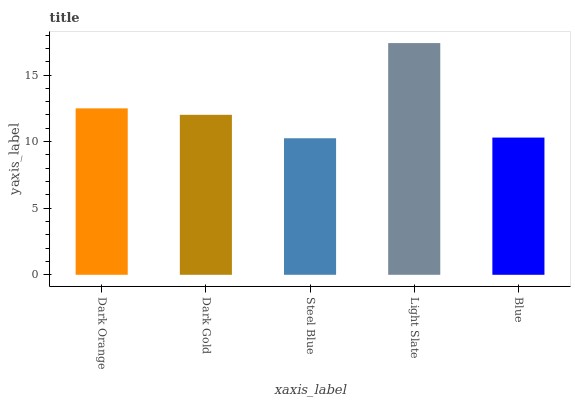Is Steel Blue the minimum?
Answer yes or no. Yes. Is Light Slate the maximum?
Answer yes or no. Yes. Is Dark Gold the minimum?
Answer yes or no. No. Is Dark Gold the maximum?
Answer yes or no. No. Is Dark Orange greater than Dark Gold?
Answer yes or no. Yes. Is Dark Gold less than Dark Orange?
Answer yes or no. Yes. Is Dark Gold greater than Dark Orange?
Answer yes or no. No. Is Dark Orange less than Dark Gold?
Answer yes or no. No. Is Dark Gold the high median?
Answer yes or no. Yes. Is Dark Gold the low median?
Answer yes or no. Yes. Is Blue the high median?
Answer yes or no. No. Is Blue the low median?
Answer yes or no. No. 